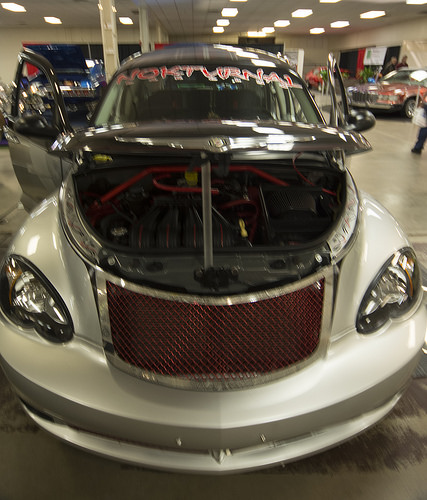<image>
Is the pole in the hood? Yes. The pole is contained within or inside the hood, showing a containment relationship. 